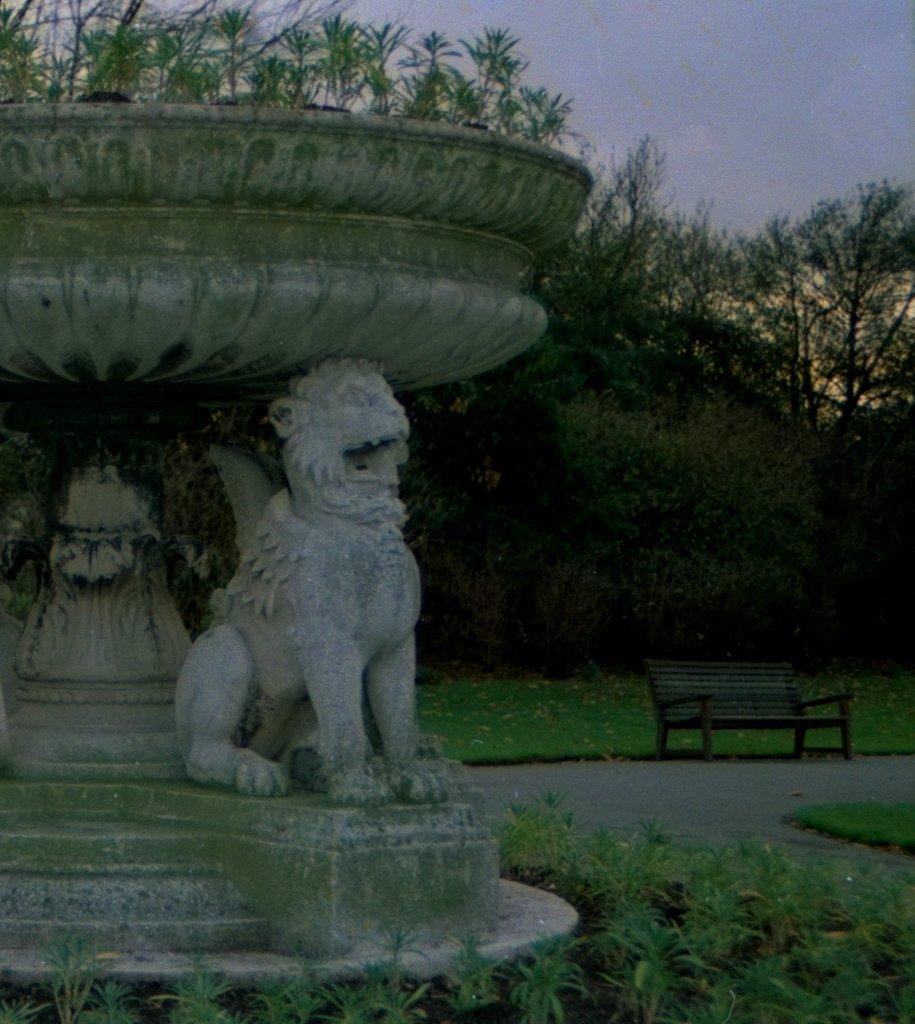Describe this image in one or two sentences. There is a sculpture of a lion in this picture. There is a bench in the park. There are some trees and sky in the background. 